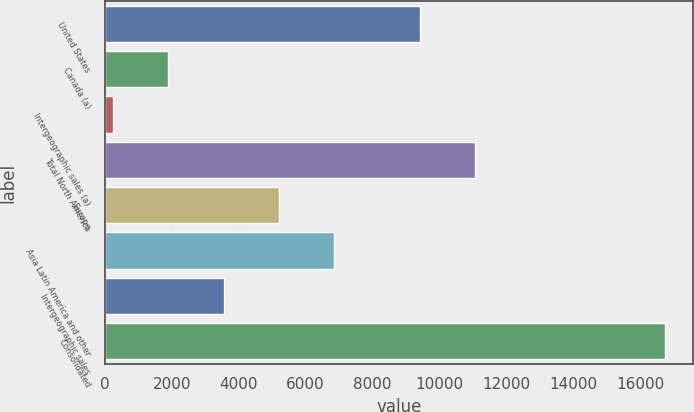Convert chart to OTSL. <chart><loc_0><loc_0><loc_500><loc_500><bar_chart><fcel>United States<fcel>Canada (a)<fcel>Intergeographic sales (a)<fcel>Total North America<fcel>Europe<fcel>Asia Latin America and other<fcel>Intergeographic sales<fcel>Consolidated<nl><fcel>9405.6<fcel>1898.97<fcel>249.2<fcel>11055.4<fcel>5198.51<fcel>6848.28<fcel>3548.74<fcel>16746.9<nl></chart> 